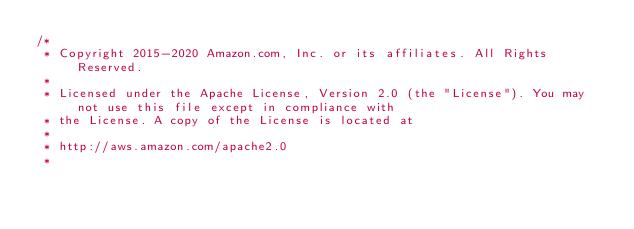Convert code to text. <code><loc_0><loc_0><loc_500><loc_500><_Java_>/*
 * Copyright 2015-2020 Amazon.com, Inc. or its affiliates. All Rights Reserved.
 * 
 * Licensed under the Apache License, Version 2.0 (the "License"). You may not use this file except in compliance with
 * the License. A copy of the License is located at
 * 
 * http://aws.amazon.com/apache2.0
 * </code> 